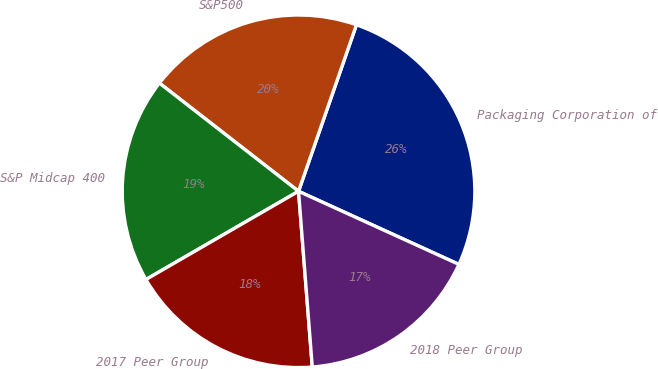<chart> <loc_0><loc_0><loc_500><loc_500><pie_chart><fcel>Packaging Corporation of<fcel>S&P500<fcel>S&P Midcap 400<fcel>2017 Peer Group<fcel>2018 Peer Group<nl><fcel>26.48%<fcel>19.81%<fcel>18.86%<fcel>17.9%<fcel>16.95%<nl></chart> 